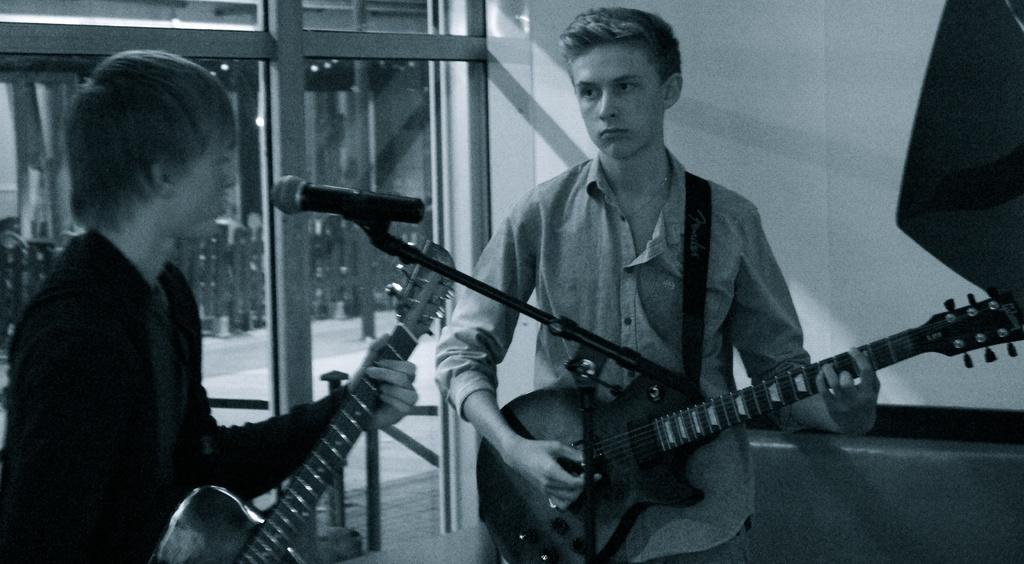Can you describe this image briefly? In this image I can see two men are standing and I can see both of them are holding guitars. I can also see a mic over here and I can see this image is black and white in colour. 